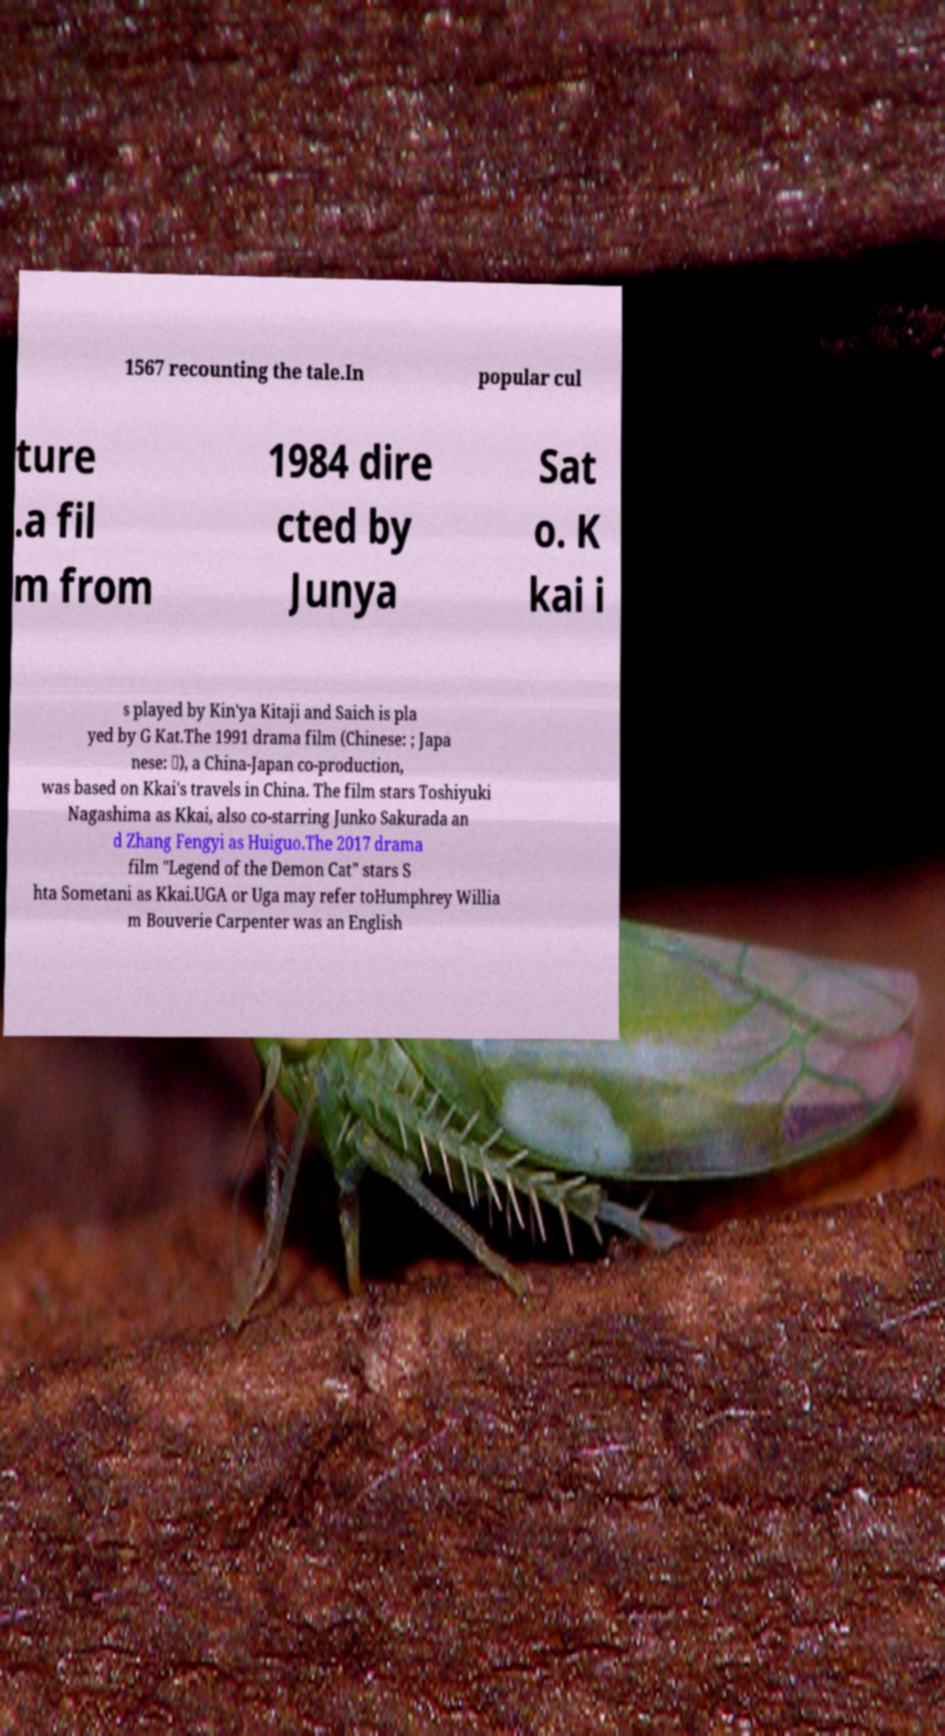Please identify and transcribe the text found in this image. 1567 recounting the tale.In popular cul ture .a fil m from 1984 dire cted by Junya Sat o. K kai i s played by Kin'ya Kitaji and Saich is pla yed by G Kat.The 1991 drama film (Chinese: ; Japa nese: ・), a China-Japan co-production, was based on Kkai's travels in China. The film stars Toshiyuki Nagashima as Kkai, also co-starring Junko Sakurada an d Zhang Fengyi as Huiguo.The 2017 drama film "Legend of the Demon Cat" stars S hta Sometani as Kkai.UGA or Uga may refer toHumphrey Willia m Bouverie Carpenter was an English 